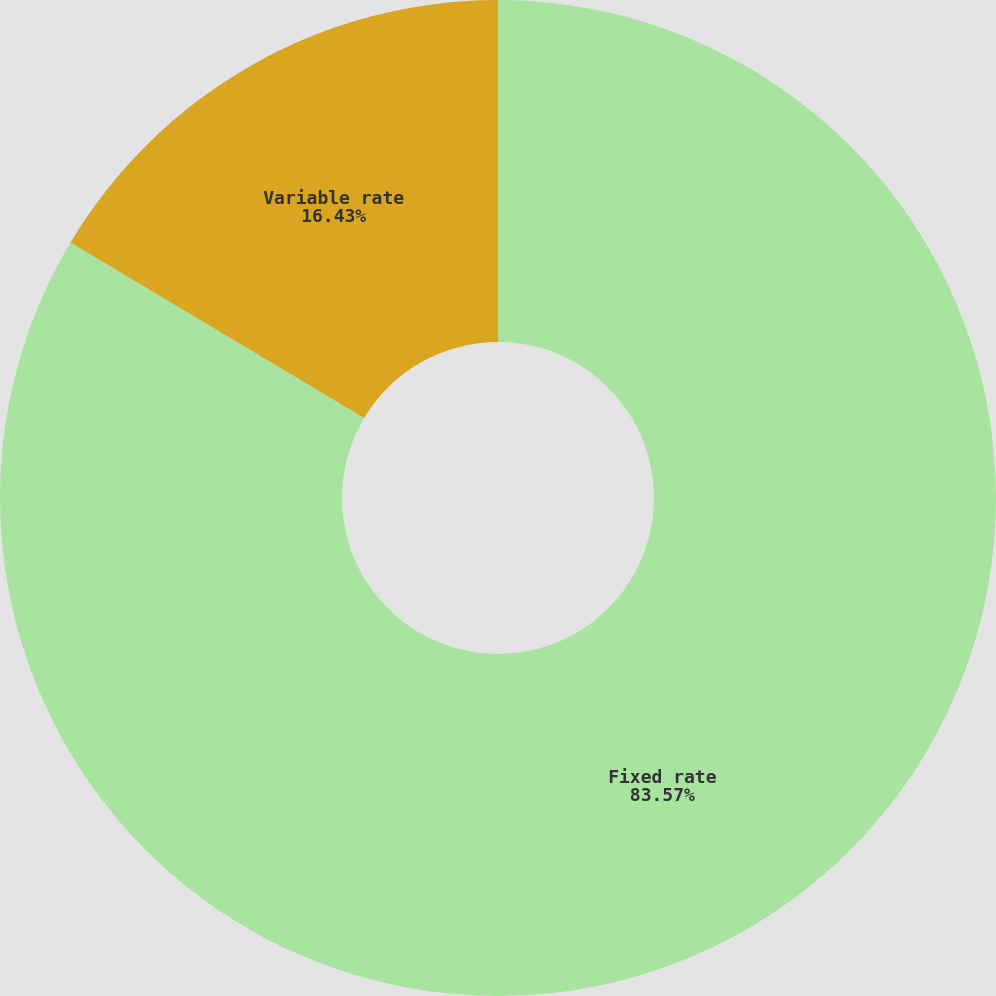Convert chart. <chart><loc_0><loc_0><loc_500><loc_500><pie_chart><fcel>Fixed rate<fcel>Variable rate<nl><fcel>83.57%<fcel>16.43%<nl></chart> 